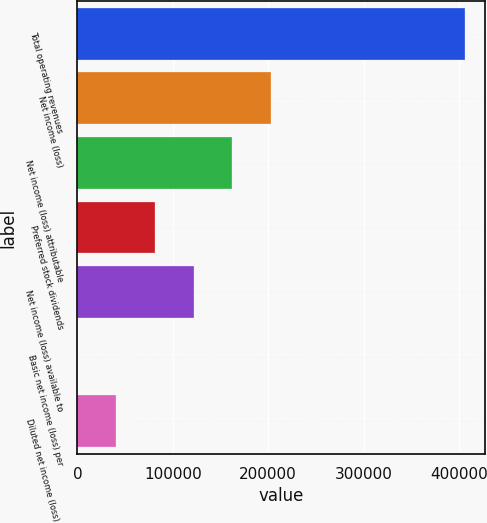<chart> <loc_0><loc_0><loc_500><loc_500><bar_chart><fcel>Total operating revenues<fcel>Net income (loss)<fcel>Net income (loss) attributable<fcel>Preferred stock dividends<fcel>Net income (loss) available to<fcel>Basic net income (loss) per<fcel>Diluted net income (loss) per<nl><fcel>406609<fcel>203305<fcel>162644<fcel>81322.4<fcel>121983<fcel>0.75<fcel>40661.6<nl></chart> 